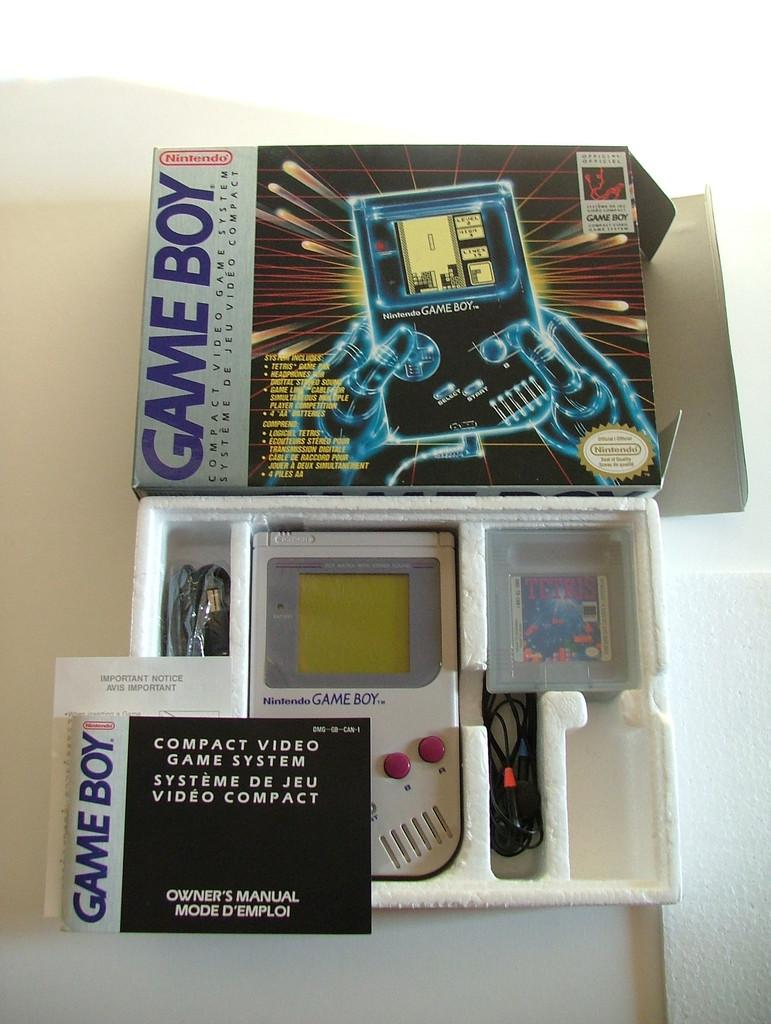<image>
Give a short and clear explanation of the subsequent image. Game Boy box by Nintendo with the console inside. 